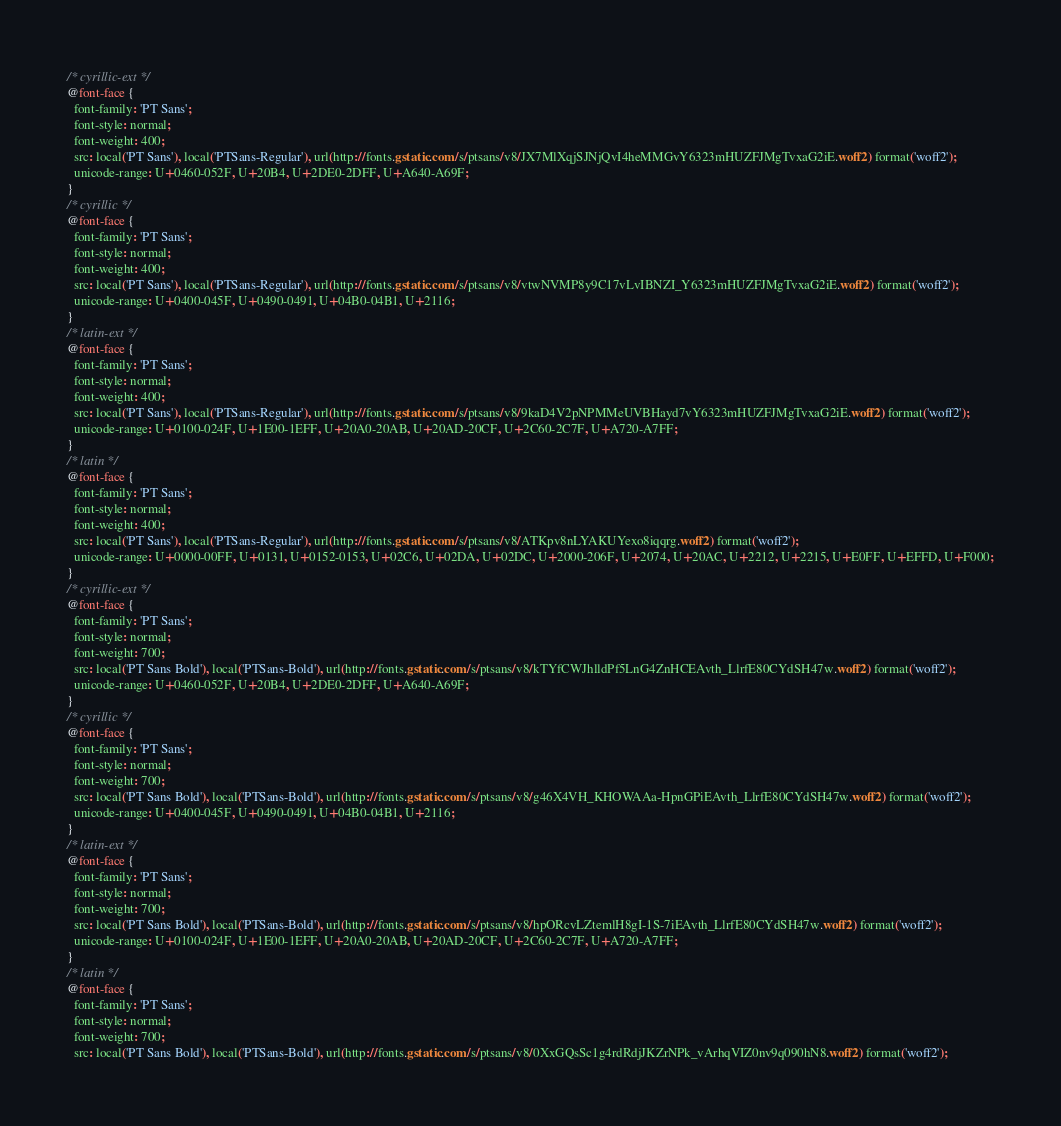Convert code to text. <code><loc_0><loc_0><loc_500><loc_500><_CSS_>/* cyrillic-ext */
@font-face {
  font-family: 'PT Sans';
  font-style: normal;
  font-weight: 400;
  src: local('PT Sans'), local('PTSans-Regular'), url(http://fonts.gstatic.com/s/ptsans/v8/JX7MlXqjSJNjQvI4heMMGvY6323mHUZFJMgTvxaG2iE.woff2) format('woff2');
  unicode-range: U+0460-052F, U+20B4, U+2DE0-2DFF, U+A640-A69F;
}
/* cyrillic */
@font-face {
  font-family: 'PT Sans';
  font-style: normal;
  font-weight: 400;
  src: local('PT Sans'), local('PTSans-Regular'), url(http://fonts.gstatic.com/s/ptsans/v8/vtwNVMP8y9C17vLvIBNZI_Y6323mHUZFJMgTvxaG2iE.woff2) format('woff2');
  unicode-range: U+0400-045F, U+0490-0491, U+04B0-04B1, U+2116;
}
/* latin-ext */
@font-face {
  font-family: 'PT Sans';
  font-style: normal;
  font-weight: 400;
  src: local('PT Sans'), local('PTSans-Regular'), url(http://fonts.gstatic.com/s/ptsans/v8/9kaD4V2pNPMMeUVBHayd7vY6323mHUZFJMgTvxaG2iE.woff2) format('woff2');
  unicode-range: U+0100-024F, U+1E00-1EFF, U+20A0-20AB, U+20AD-20CF, U+2C60-2C7F, U+A720-A7FF;
}
/* latin */
@font-face {
  font-family: 'PT Sans';
  font-style: normal;
  font-weight: 400;
  src: local('PT Sans'), local('PTSans-Regular'), url(http://fonts.gstatic.com/s/ptsans/v8/ATKpv8nLYAKUYexo8iqqrg.woff2) format('woff2');
  unicode-range: U+0000-00FF, U+0131, U+0152-0153, U+02C6, U+02DA, U+02DC, U+2000-206F, U+2074, U+20AC, U+2212, U+2215, U+E0FF, U+EFFD, U+F000;
}
/* cyrillic-ext */
@font-face {
  font-family: 'PT Sans';
  font-style: normal;
  font-weight: 700;
  src: local('PT Sans Bold'), local('PTSans-Bold'), url(http://fonts.gstatic.com/s/ptsans/v8/kTYfCWJhlldPf5LnG4ZnHCEAvth_LlrfE80CYdSH47w.woff2) format('woff2');
  unicode-range: U+0460-052F, U+20B4, U+2DE0-2DFF, U+A640-A69F;
}
/* cyrillic */
@font-face {
  font-family: 'PT Sans';
  font-style: normal;
  font-weight: 700;
  src: local('PT Sans Bold'), local('PTSans-Bold'), url(http://fonts.gstatic.com/s/ptsans/v8/g46X4VH_KHOWAAa-HpnGPiEAvth_LlrfE80CYdSH47w.woff2) format('woff2');
  unicode-range: U+0400-045F, U+0490-0491, U+04B0-04B1, U+2116;
}
/* latin-ext */
@font-face {
  font-family: 'PT Sans';
  font-style: normal;
  font-weight: 700;
  src: local('PT Sans Bold'), local('PTSans-Bold'), url(http://fonts.gstatic.com/s/ptsans/v8/hpORcvLZtemlH8gI-1S-7iEAvth_LlrfE80CYdSH47w.woff2) format('woff2');
  unicode-range: U+0100-024F, U+1E00-1EFF, U+20A0-20AB, U+20AD-20CF, U+2C60-2C7F, U+A720-A7FF;
}
/* latin */
@font-face {
  font-family: 'PT Sans';
  font-style: normal;
  font-weight: 700;
  src: local('PT Sans Bold'), local('PTSans-Bold'), url(http://fonts.gstatic.com/s/ptsans/v8/0XxGQsSc1g4rdRdjJKZrNPk_vArhqVIZ0nv9q090hN8.woff2) format('woff2');</code> 